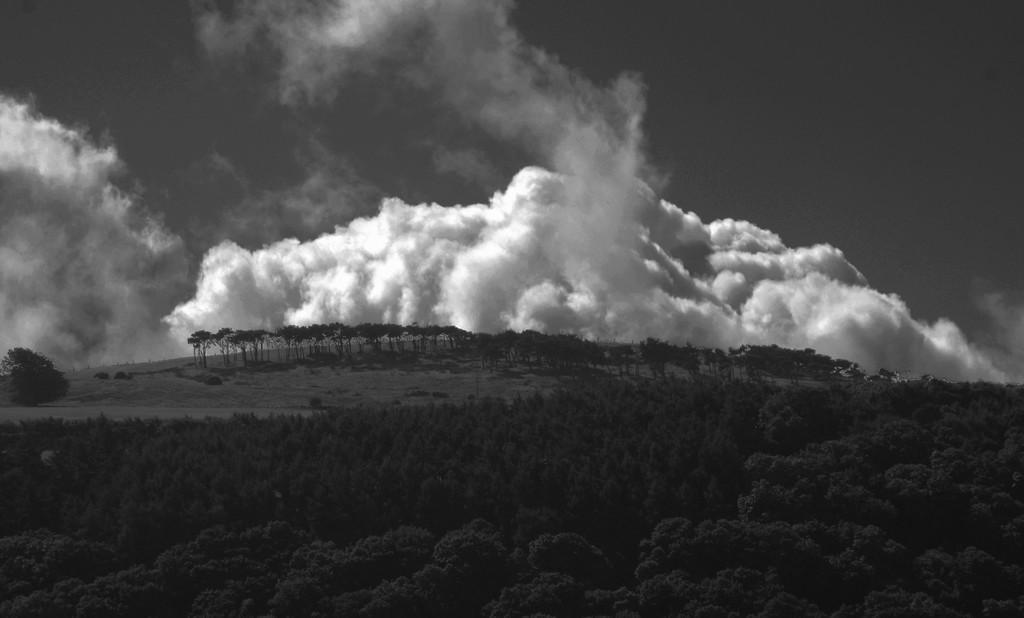Could you give a brief overview of what you see in this image? In this picture I can see the trees in the middle, at the top there is the sky. This image is in black and white color. 